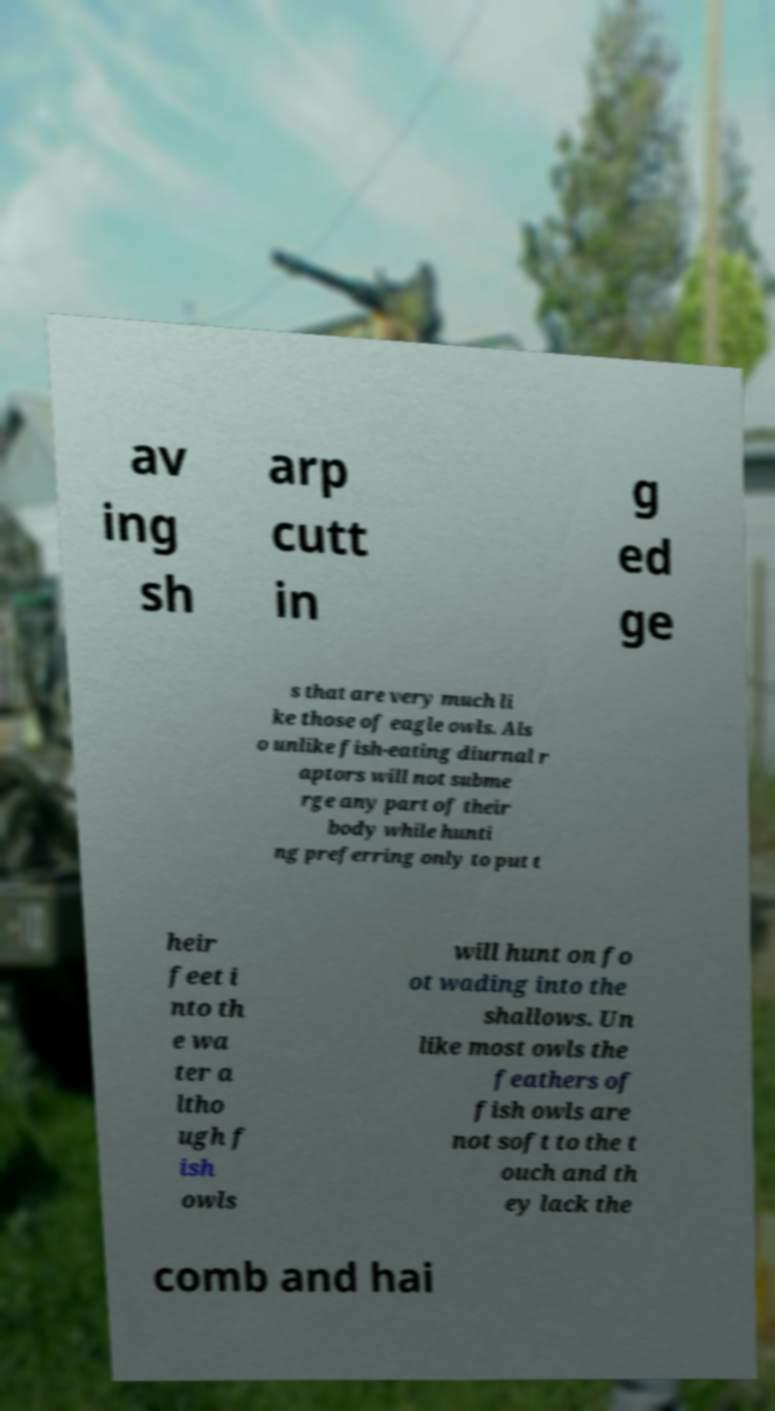For documentation purposes, I need the text within this image transcribed. Could you provide that? av ing sh arp cutt in g ed ge s that are very much li ke those of eagle owls. Als o unlike fish-eating diurnal r aptors will not subme rge any part of their body while hunti ng preferring only to put t heir feet i nto th e wa ter a ltho ugh f ish owls will hunt on fo ot wading into the shallows. Un like most owls the feathers of fish owls are not soft to the t ouch and th ey lack the comb and hai 